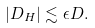<formula> <loc_0><loc_0><loc_500><loc_500>\left | D _ { H } \right | \lesssim \epsilon D .</formula> 